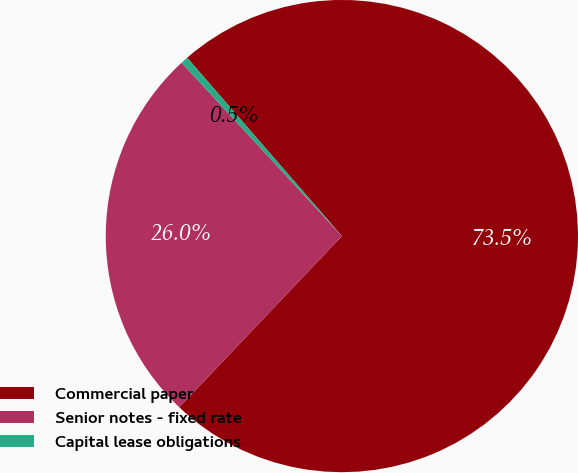<chart> <loc_0><loc_0><loc_500><loc_500><pie_chart><fcel>Commercial paper<fcel>Senior notes - fixed rate<fcel>Capital lease obligations<nl><fcel>73.47%<fcel>26.04%<fcel>0.5%<nl></chart> 